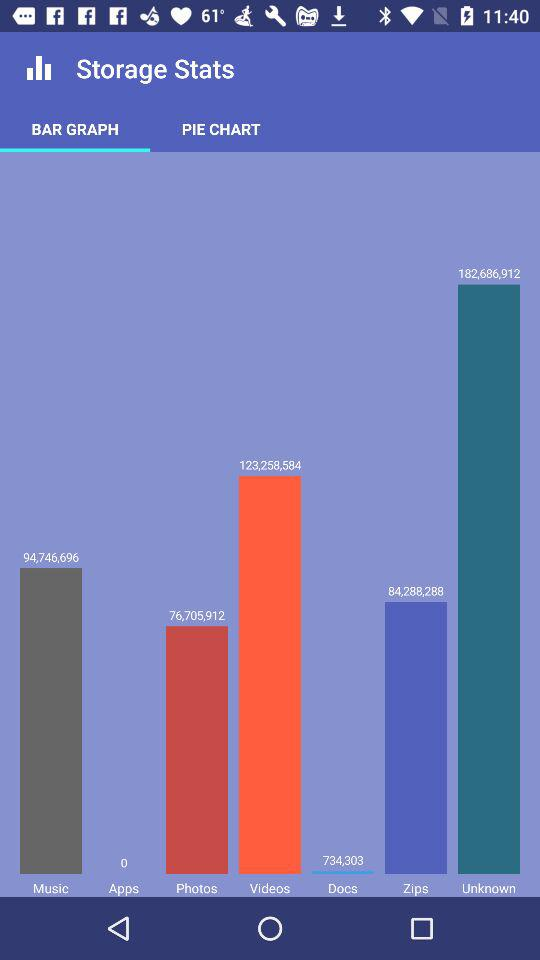What is the number of videos? There are 123,258,584 videos. 